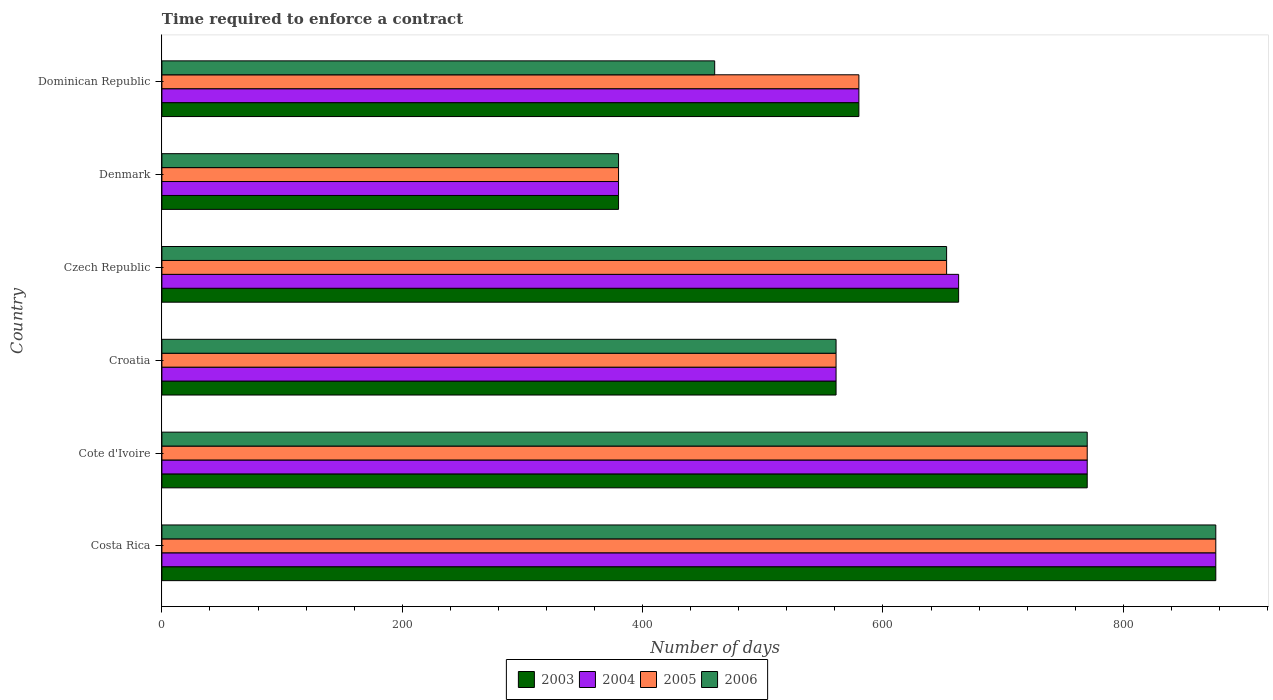How many groups of bars are there?
Give a very brief answer. 6. How many bars are there on the 4th tick from the top?
Ensure brevity in your answer.  4. What is the label of the 4th group of bars from the top?
Keep it short and to the point. Croatia. What is the number of days required to enforce a contract in 2004 in Cote d'Ivoire?
Offer a terse response. 770. Across all countries, what is the maximum number of days required to enforce a contract in 2003?
Provide a short and direct response. 877. Across all countries, what is the minimum number of days required to enforce a contract in 2006?
Provide a succinct answer. 380. In which country was the number of days required to enforce a contract in 2003 maximum?
Your answer should be compact. Costa Rica. In which country was the number of days required to enforce a contract in 2005 minimum?
Ensure brevity in your answer.  Denmark. What is the total number of days required to enforce a contract in 2005 in the graph?
Offer a very short reply. 3821. What is the difference between the number of days required to enforce a contract in 2005 in Croatia and that in Denmark?
Keep it short and to the point. 181. What is the difference between the number of days required to enforce a contract in 2005 in Croatia and the number of days required to enforce a contract in 2004 in Costa Rica?
Offer a very short reply. -316. What is the average number of days required to enforce a contract in 2006 per country?
Make the answer very short. 616.83. In how many countries, is the number of days required to enforce a contract in 2004 greater than 840 days?
Your answer should be very brief. 1. What is the ratio of the number of days required to enforce a contract in 2006 in Czech Republic to that in Denmark?
Provide a short and direct response. 1.72. Is the number of days required to enforce a contract in 2005 in Cote d'Ivoire less than that in Dominican Republic?
Your response must be concise. No. Is the difference between the number of days required to enforce a contract in 2004 in Cote d'Ivoire and Dominican Republic greater than the difference between the number of days required to enforce a contract in 2005 in Cote d'Ivoire and Dominican Republic?
Provide a short and direct response. No. What is the difference between the highest and the second highest number of days required to enforce a contract in 2005?
Make the answer very short. 107. What is the difference between the highest and the lowest number of days required to enforce a contract in 2004?
Offer a very short reply. 497. Is the sum of the number of days required to enforce a contract in 2005 in Cote d'Ivoire and Dominican Republic greater than the maximum number of days required to enforce a contract in 2004 across all countries?
Provide a short and direct response. Yes. Is it the case that in every country, the sum of the number of days required to enforce a contract in 2003 and number of days required to enforce a contract in 2006 is greater than the sum of number of days required to enforce a contract in 2004 and number of days required to enforce a contract in 2005?
Your answer should be compact. No. What does the 3rd bar from the top in Croatia represents?
Your answer should be compact. 2004. Is it the case that in every country, the sum of the number of days required to enforce a contract in 2003 and number of days required to enforce a contract in 2005 is greater than the number of days required to enforce a contract in 2006?
Give a very brief answer. Yes. How many countries are there in the graph?
Your answer should be compact. 6. What is the difference between two consecutive major ticks on the X-axis?
Make the answer very short. 200. Are the values on the major ticks of X-axis written in scientific E-notation?
Your answer should be very brief. No. Does the graph contain any zero values?
Offer a terse response. No. How are the legend labels stacked?
Provide a succinct answer. Horizontal. What is the title of the graph?
Provide a short and direct response. Time required to enforce a contract. Does "2015" appear as one of the legend labels in the graph?
Your response must be concise. No. What is the label or title of the X-axis?
Give a very brief answer. Number of days. What is the Number of days in 2003 in Costa Rica?
Make the answer very short. 877. What is the Number of days of 2004 in Costa Rica?
Your answer should be compact. 877. What is the Number of days in 2005 in Costa Rica?
Provide a succinct answer. 877. What is the Number of days in 2006 in Costa Rica?
Your response must be concise. 877. What is the Number of days in 2003 in Cote d'Ivoire?
Provide a succinct answer. 770. What is the Number of days in 2004 in Cote d'Ivoire?
Give a very brief answer. 770. What is the Number of days of 2005 in Cote d'Ivoire?
Provide a short and direct response. 770. What is the Number of days in 2006 in Cote d'Ivoire?
Your answer should be compact. 770. What is the Number of days of 2003 in Croatia?
Offer a very short reply. 561. What is the Number of days of 2004 in Croatia?
Give a very brief answer. 561. What is the Number of days in 2005 in Croatia?
Your response must be concise. 561. What is the Number of days in 2006 in Croatia?
Give a very brief answer. 561. What is the Number of days in 2003 in Czech Republic?
Your response must be concise. 663. What is the Number of days in 2004 in Czech Republic?
Give a very brief answer. 663. What is the Number of days of 2005 in Czech Republic?
Ensure brevity in your answer.  653. What is the Number of days of 2006 in Czech Republic?
Your answer should be very brief. 653. What is the Number of days of 2003 in Denmark?
Provide a short and direct response. 380. What is the Number of days in 2004 in Denmark?
Give a very brief answer. 380. What is the Number of days in 2005 in Denmark?
Ensure brevity in your answer.  380. What is the Number of days in 2006 in Denmark?
Ensure brevity in your answer.  380. What is the Number of days in 2003 in Dominican Republic?
Your response must be concise. 580. What is the Number of days in 2004 in Dominican Republic?
Offer a terse response. 580. What is the Number of days of 2005 in Dominican Republic?
Give a very brief answer. 580. What is the Number of days in 2006 in Dominican Republic?
Provide a short and direct response. 460. Across all countries, what is the maximum Number of days in 2003?
Give a very brief answer. 877. Across all countries, what is the maximum Number of days of 2004?
Offer a terse response. 877. Across all countries, what is the maximum Number of days of 2005?
Give a very brief answer. 877. Across all countries, what is the maximum Number of days of 2006?
Offer a terse response. 877. Across all countries, what is the minimum Number of days in 2003?
Your answer should be very brief. 380. Across all countries, what is the minimum Number of days in 2004?
Provide a short and direct response. 380. Across all countries, what is the minimum Number of days in 2005?
Provide a short and direct response. 380. Across all countries, what is the minimum Number of days in 2006?
Your answer should be compact. 380. What is the total Number of days in 2003 in the graph?
Offer a very short reply. 3831. What is the total Number of days of 2004 in the graph?
Keep it short and to the point. 3831. What is the total Number of days of 2005 in the graph?
Provide a short and direct response. 3821. What is the total Number of days in 2006 in the graph?
Your answer should be very brief. 3701. What is the difference between the Number of days of 2003 in Costa Rica and that in Cote d'Ivoire?
Offer a very short reply. 107. What is the difference between the Number of days of 2004 in Costa Rica and that in Cote d'Ivoire?
Offer a very short reply. 107. What is the difference between the Number of days in 2005 in Costa Rica and that in Cote d'Ivoire?
Your response must be concise. 107. What is the difference between the Number of days in 2006 in Costa Rica and that in Cote d'Ivoire?
Ensure brevity in your answer.  107. What is the difference between the Number of days in 2003 in Costa Rica and that in Croatia?
Your answer should be very brief. 316. What is the difference between the Number of days of 2004 in Costa Rica and that in Croatia?
Your answer should be very brief. 316. What is the difference between the Number of days of 2005 in Costa Rica and that in Croatia?
Make the answer very short. 316. What is the difference between the Number of days in 2006 in Costa Rica and that in Croatia?
Make the answer very short. 316. What is the difference between the Number of days in 2003 in Costa Rica and that in Czech Republic?
Give a very brief answer. 214. What is the difference between the Number of days of 2004 in Costa Rica and that in Czech Republic?
Your response must be concise. 214. What is the difference between the Number of days of 2005 in Costa Rica and that in Czech Republic?
Offer a very short reply. 224. What is the difference between the Number of days in 2006 in Costa Rica and that in Czech Republic?
Keep it short and to the point. 224. What is the difference between the Number of days of 2003 in Costa Rica and that in Denmark?
Your response must be concise. 497. What is the difference between the Number of days in 2004 in Costa Rica and that in Denmark?
Make the answer very short. 497. What is the difference between the Number of days in 2005 in Costa Rica and that in Denmark?
Offer a very short reply. 497. What is the difference between the Number of days of 2006 in Costa Rica and that in Denmark?
Your answer should be very brief. 497. What is the difference between the Number of days in 2003 in Costa Rica and that in Dominican Republic?
Keep it short and to the point. 297. What is the difference between the Number of days in 2004 in Costa Rica and that in Dominican Republic?
Provide a succinct answer. 297. What is the difference between the Number of days of 2005 in Costa Rica and that in Dominican Republic?
Your response must be concise. 297. What is the difference between the Number of days of 2006 in Costa Rica and that in Dominican Republic?
Keep it short and to the point. 417. What is the difference between the Number of days of 2003 in Cote d'Ivoire and that in Croatia?
Your response must be concise. 209. What is the difference between the Number of days of 2004 in Cote d'Ivoire and that in Croatia?
Make the answer very short. 209. What is the difference between the Number of days of 2005 in Cote d'Ivoire and that in Croatia?
Provide a short and direct response. 209. What is the difference between the Number of days of 2006 in Cote d'Ivoire and that in Croatia?
Give a very brief answer. 209. What is the difference between the Number of days of 2003 in Cote d'Ivoire and that in Czech Republic?
Your answer should be compact. 107. What is the difference between the Number of days in 2004 in Cote d'Ivoire and that in Czech Republic?
Keep it short and to the point. 107. What is the difference between the Number of days of 2005 in Cote d'Ivoire and that in Czech Republic?
Make the answer very short. 117. What is the difference between the Number of days of 2006 in Cote d'Ivoire and that in Czech Republic?
Your response must be concise. 117. What is the difference between the Number of days of 2003 in Cote d'Ivoire and that in Denmark?
Your answer should be very brief. 390. What is the difference between the Number of days in 2004 in Cote d'Ivoire and that in Denmark?
Make the answer very short. 390. What is the difference between the Number of days in 2005 in Cote d'Ivoire and that in Denmark?
Your answer should be very brief. 390. What is the difference between the Number of days in 2006 in Cote d'Ivoire and that in Denmark?
Keep it short and to the point. 390. What is the difference between the Number of days in 2003 in Cote d'Ivoire and that in Dominican Republic?
Offer a very short reply. 190. What is the difference between the Number of days in 2004 in Cote d'Ivoire and that in Dominican Republic?
Provide a short and direct response. 190. What is the difference between the Number of days in 2005 in Cote d'Ivoire and that in Dominican Republic?
Provide a succinct answer. 190. What is the difference between the Number of days in 2006 in Cote d'Ivoire and that in Dominican Republic?
Offer a very short reply. 310. What is the difference between the Number of days in 2003 in Croatia and that in Czech Republic?
Offer a very short reply. -102. What is the difference between the Number of days of 2004 in Croatia and that in Czech Republic?
Give a very brief answer. -102. What is the difference between the Number of days of 2005 in Croatia and that in Czech Republic?
Give a very brief answer. -92. What is the difference between the Number of days in 2006 in Croatia and that in Czech Republic?
Provide a short and direct response. -92. What is the difference between the Number of days in 2003 in Croatia and that in Denmark?
Ensure brevity in your answer.  181. What is the difference between the Number of days in 2004 in Croatia and that in Denmark?
Keep it short and to the point. 181. What is the difference between the Number of days in 2005 in Croatia and that in Denmark?
Offer a terse response. 181. What is the difference between the Number of days of 2006 in Croatia and that in Denmark?
Make the answer very short. 181. What is the difference between the Number of days in 2006 in Croatia and that in Dominican Republic?
Your answer should be compact. 101. What is the difference between the Number of days of 2003 in Czech Republic and that in Denmark?
Give a very brief answer. 283. What is the difference between the Number of days of 2004 in Czech Republic and that in Denmark?
Offer a very short reply. 283. What is the difference between the Number of days of 2005 in Czech Republic and that in Denmark?
Keep it short and to the point. 273. What is the difference between the Number of days of 2006 in Czech Republic and that in Denmark?
Your answer should be compact. 273. What is the difference between the Number of days of 2003 in Czech Republic and that in Dominican Republic?
Ensure brevity in your answer.  83. What is the difference between the Number of days in 2004 in Czech Republic and that in Dominican Republic?
Provide a short and direct response. 83. What is the difference between the Number of days of 2006 in Czech Republic and that in Dominican Republic?
Provide a succinct answer. 193. What is the difference between the Number of days in 2003 in Denmark and that in Dominican Republic?
Give a very brief answer. -200. What is the difference between the Number of days of 2004 in Denmark and that in Dominican Republic?
Your response must be concise. -200. What is the difference between the Number of days in 2005 in Denmark and that in Dominican Republic?
Provide a short and direct response. -200. What is the difference between the Number of days in 2006 in Denmark and that in Dominican Republic?
Make the answer very short. -80. What is the difference between the Number of days in 2003 in Costa Rica and the Number of days in 2004 in Cote d'Ivoire?
Offer a very short reply. 107. What is the difference between the Number of days in 2003 in Costa Rica and the Number of days in 2005 in Cote d'Ivoire?
Your response must be concise. 107. What is the difference between the Number of days of 2003 in Costa Rica and the Number of days of 2006 in Cote d'Ivoire?
Provide a succinct answer. 107. What is the difference between the Number of days of 2004 in Costa Rica and the Number of days of 2005 in Cote d'Ivoire?
Your answer should be very brief. 107. What is the difference between the Number of days of 2004 in Costa Rica and the Number of days of 2006 in Cote d'Ivoire?
Make the answer very short. 107. What is the difference between the Number of days in 2005 in Costa Rica and the Number of days in 2006 in Cote d'Ivoire?
Keep it short and to the point. 107. What is the difference between the Number of days of 2003 in Costa Rica and the Number of days of 2004 in Croatia?
Offer a terse response. 316. What is the difference between the Number of days of 2003 in Costa Rica and the Number of days of 2005 in Croatia?
Your answer should be very brief. 316. What is the difference between the Number of days in 2003 in Costa Rica and the Number of days in 2006 in Croatia?
Make the answer very short. 316. What is the difference between the Number of days of 2004 in Costa Rica and the Number of days of 2005 in Croatia?
Provide a succinct answer. 316. What is the difference between the Number of days in 2004 in Costa Rica and the Number of days in 2006 in Croatia?
Your answer should be very brief. 316. What is the difference between the Number of days in 2005 in Costa Rica and the Number of days in 2006 in Croatia?
Provide a short and direct response. 316. What is the difference between the Number of days in 2003 in Costa Rica and the Number of days in 2004 in Czech Republic?
Make the answer very short. 214. What is the difference between the Number of days in 2003 in Costa Rica and the Number of days in 2005 in Czech Republic?
Provide a succinct answer. 224. What is the difference between the Number of days of 2003 in Costa Rica and the Number of days of 2006 in Czech Republic?
Offer a very short reply. 224. What is the difference between the Number of days in 2004 in Costa Rica and the Number of days in 2005 in Czech Republic?
Your answer should be compact. 224. What is the difference between the Number of days in 2004 in Costa Rica and the Number of days in 2006 in Czech Republic?
Your answer should be compact. 224. What is the difference between the Number of days of 2005 in Costa Rica and the Number of days of 2006 in Czech Republic?
Provide a succinct answer. 224. What is the difference between the Number of days of 2003 in Costa Rica and the Number of days of 2004 in Denmark?
Give a very brief answer. 497. What is the difference between the Number of days of 2003 in Costa Rica and the Number of days of 2005 in Denmark?
Offer a terse response. 497. What is the difference between the Number of days in 2003 in Costa Rica and the Number of days in 2006 in Denmark?
Ensure brevity in your answer.  497. What is the difference between the Number of days of 2004 in Costa Rica and the Number of days of 2005 in Denmark?
Make the answer very short. 497. What is the difference between the Number of days of 2004 in Costa Rica and the Number of days of 2006 in Denmark?
Your answer should be very brief. 497. What is the difference between the Number of days in 2005 in Costa Rica and the Number of days in 2006 in Denmark?
Your answer should be very brief. 497. What is the difference between the Number of days in 2003 in Costa Rica and the Number of days in 2004 in Dominican Republic?
Provide a succinct answer. 297. What is the difference between the Number of days in 2003 in Costa Rica and the Number of days in 2005 in Dominican Republic?
Give a very brief answer. 297. What is the difference between the Number of days of 2003 in Costa Rica and the Number of days of 2006 in Dominican Republic?
Ensure brevity in your answer.  417. What is the difference between the Number of days in 2004 in Costa Rica and the Number of days in 2005 in Dominican Republic?
Give a very brief answer. 297. What is the difference between the Number of days in 2004 in Costa Rica and the Number of days in 2006 in Dominican Republic?
Give a very brief answer. 417. What is the difference between the Number of days of 2005 in Costa Rica and the Number of days of 2006 in Dominican Republic?
Provide a short and direct response. 417. What is the difference between the Number of days in 2003 in Cote d'Ivoire and the Number of days in 2004 in Croatia?
Give a very brief answer. 209. What is the difference between the Number of days in 2003 in Cote d'Ivoire and the Number of days in 2005 in Croatia?
Your answer should be compact. 209. What is the difference between the Number of days in 2003 in Cote d'Ivoire and the Number of days in 2006 in Croatia?
Your answer should be compact. 209. What is the difference between the Number of days of 2004 in Cote d'Ivoire and the Number of days of 2005 in Croatia?
Keep it short and to the point. 209. What is the difference between the Number of days in 2004 in Cote d'Ivoire and the Number of days in 2006 in Croatia?
Give a very brief answer. 209. What is the difference between the Number of days in 2005 in Cote d'Ivoire and the Number of days in 2006 in Croatia?
Keep it short and to the point. 209. What is the difference between the Number of days of 2003 in Cote d'Ivoire and the Number of days of 2004 in Czech Republic?
Ensure brevity in your answer.  107. What is the difference between the Number of days of 2003 in Cote d'Ivoire and the Number of days of 2005 in Czech Republic?
Give a very brief answer. 117. What is the difference between the Number of days in 2003 in Cote d'Ivoire and the Number of days in 2006 in Czech Republic?
Your answer should be compact. 117. What is the difference between the Number of days of 2004 in Cote d'Ivoire and the Number of days of 2005 in Czech Republic?
Provide a short and direct response. 117. What is the difference between the Number of days of 2004 in Cote d'Ivoire and the Number of days of 2006 in Czech Republic?
Your answer should be very brief. 117. What is the difference between the Number of days of 2005 in Cote d'Ivoire and the Number of days of 2006 in Czech Republic?
Your response must be concise. 117. What is the difference between the Number of days in 2003 in Cote d'Ivoire and the Number of days in 2004 in Denmark?
Make the answer very short. 390. What is the difference between the Number of days of 2003 in Cote d'Ivoire and the Number of days of 2005 in Denmark?
Provide a succinct answer. 390. What is the difference between the Number of days of 2003 in Cote d'Ivoire and the Number of days of 2006 in Denmark?
Ensure brevity in your answer.  390. What is the difference between the Number of days of 2004 in Cote d'Ivoire and the Number of days of 2005 in Denmark?
Make the answer very short. 390. What is the difference between the Number of days in 2004 in Cote d'Ivoire and the Number of days in 2006 in Denmark?
Provide a succinct answer. 390. What is the difference between the Number of days of 2005 in Cote d'Ivoire and the Number of days of 2006 in Denmark?
Provide a succinct answer. 390. What is the difference between the Number of days in 2003 in Cote d'Ivoire and the Number of days in 2004 in Dominican Republic?
Your answer should be very brief. 190. What is the difference between the Number of days in 2003 in Cote d'Ivoire and the Number of days in 2005 in Dominican Republic?
Offer a terse response. 190. What is the difference between the Number of days in 2003 in Cote d'Ivoire and the Number of days in 2006 in Dominican Republic?
Make the answer very short. 310. What is the difference between the Number of days in 2004 in Cote d'Ivoire and the Number of days in 2005 in Dominican Republic?
Your answer should be compact. 190. What is the difference between the Number of days of 2004 in Cote d'Ivoire and the Number of days of 2006 in Dominican Republic?
Give a very brief answer. 310. What is the difference between the Number of days of 2005 in Cote d'Ivoire and the Number of days of 2006 in Dominican Republic?
Offer a terse response. 310. What is the difference between the Number of days of 2003 in Croatia and the Number of days of 2004 in Czech Republic?
Ensure brevity in your answer.  -102. What is the difference between the Number of days in 2003 in Croatia and the Number of days in 2005 in Czech Republic?
Offer a very short reply. -92. What is the difference between the Number of days of 2003 in Croatia and the Number of days of 2006 in Czech Republic?
Give a very brief answer. -92. What is the difference between the Number of days in 2004 in Croatia and the Number of days in 2005 in Czech Republic?
Your answer should be compact. -92. What is the difference between the Number of days of 2004 in Croatia and the Number of days of 2006 in Czech Republic?
Keep it short and to the point. -92. What is the difference between the Number of days in 2005 in Croatia and the Number of days in 2006 in Czech Republic?
Provide a succinct answer. -92. What is the difference between the Number of days of 2003 in Croatia and the Number of days of 2004 in Denmark?
Ensure brevity in your answer.  181. What is the difference between the Number of days of 2003 in Croatia and the Number of days of 2005 in Denmark?
Provide a succinct answer. 181. What is the difference between the Number of days in 2003 in Croatia and the Number of days in 2006 in Denmark?
Ensure brevity in your answer.  181. What is the difference between the Number of days in 2004 in Croatia and the Number of days in 2005 in Denmark?
Keep it short and to the point. 181. What is the difference between the Number of days of 2004 in Croatia and the Number of days of 2006 in Denmark?
Give a very brief answer. 181. What is the difference between the Number of days in 2005 in Croatia and the Number of days in 2006 in Denmark?
Offer a terse response. 181. What is the difference between the Number of days of 2003 in Croatia and the Number of days of 2004 in Dominican Republic?
Make the answer very short. -19. What is the difference between the Number of days of 2003 in Croatia and the Number of days of 2006 in Dominican Republic?
Your answer should be compact. 101. What is the difference between the Number of days of 2004 in Croatia and the Number of days of 2005 in Dominican Republic?
Offer a very short reply. -19. What is the difference between the Number of days in 2004 in Croatia and the Number of days in 2006 in Dominican Republic?
Provide a short and direct response. 101. What is the difference between the Number of days of 2005 in Croatia and the Number of days of 2006 in Dominican Republic?
Your answer should be very brief. 101. What is the difference between the Number of days of 2003 in Czech Republic and the Number of days of 2004 in Denmark?
Offer a terse response. 283. What is the difference between the Number of days of 2003 in Czech Republic and the Number of days of 2005 in Denmark?
Your answer should be compact. 283. What is the difference between the Number of days of 2003 in Czech Republic and the Number of days of 2006 in Denmark?
Keep it short and to the point. 283. What is the difference between the Number of days of 2004 in Czech Republic and the Number of days of 2005 in Denmark?
Your answer should be very brief. 283. What is the difference between the Number of days in 2004 in Czech Republic and the Number of days in 2006 in Denmark?
Your answer should be compact. 283. What is the difference between the Number of days of 2005 in Czech Republic and the Number of days of 2006 in Denmark?
Offer a terse response. 273. What is the difference between the Number of days of 2003 in Czech Republic and the Number of days of 2005 in Dominican Republic?
Your response must be concise. 83. What is the difference between the Number of days of 2003 in Czech Republic and the Number of days of 2006 in Dominican Republic?
Ensure brevity in your answer.  203. What is the difference between the Number of days of 2004 in Czech Republic and the Number of days of 2005 in Dominican Republic?
Your response must be concise. 83. What is the difference between the Number of days in 2004 in Czech Republic and the Number of days in 2006 in Dominican Republic?
Your answer should be very brief. 203. What is the difference between the Number of days in 2005 in Czech Republic and the Number of days in 2006 in Dominican Republic?
Make the answer very short. 193. What is the difference between the Number of days of 2003 in Denmark and the Number of days of 2004 in Dominican Republic?
Ensure brevity in your answer.  -200. What is the difference between the Number of days of 2003 in Denmark and the Number of days of 2005 in Dominican Republic?
Your answer should be very brief. -200. What is the difference between the Number of days of 2003 in Denmark and the Number of days of 2006 in Dominican Republic?
Your answer should be very brief. -80. What is the difference between the Number of days in 2004 in Denmark and the Number of days in 2005 in Dominican Republic?
Provide a short and direct response. -200. What is the difference between the Number of days of 2004 in Denmark and the Number of days of 2006 in Dominican Republic?
Provide a succinct answer. -80. What is the difference between the Number of days of 2005 in Denmark and the Number of days of 2006 in Dominican Republic?
Give a very brief answer. -80. What is the average Number of days in 2003 per country?
Your answer should be compact. 638.5. What is the average Number of days of 2004 per country?
Offer a very short reply. 638.5. What is the average Number of days of 2005 per country?
Your answer should be compact. 636.83. What is the average Number of days of 2006 per country?
Keep it short and to the point. 616.83. What is the difference between the Number of days of 2003 and Number of days of 2004 in Costa Rica?
Your answer should be very brief. 0. What is the difference between the Number of days in 2003 and Number of days in 2005 in Costa Rica?
Give a very brief answer. 0. What is the difference between the Number of days of 2003 and Number of days of 2006 in Costa Rica?
Your response must be concise. 0. What is the difference between the Number of days in 2004 and Number of days in 2005 in Costa Rica?
Your answer should be compact. 0. What is the difference between the Number of days of 2004 and Number of days of 2006 in Costa Rica?
Keep it short and to the point. 0. What is the difference between the Number of days in 2003 and Number of days in 2006 in Cote d'Ivoire?
Ensure brevity in your answer.  0. What is the difference between the Number of days of 2004 and Number of days of 2005 in Cote d'Ivoire?
Your response must be concise. 0. What is the difference between the Number of days of 2004 and Number of days of 2006 in Cote d'Ivoire?
Your answer should be compact. 0. What is the difference between the Number of days of 2005 and Number of days of 2006 in Cote d'Ivoire?
Give a very brief answer. 0. What is the difference between the Number of days of 2003 and Number of days of 2004 in Czech Republic?
Provide a succinct answer. 0. What is the difference between the Number of days of 2003 and Number of days of 2006 in Czech Republic?
Offer a terse response. 10. What is the difference between the Number of days in 2004 and Number of days in 2005 in Czech Republic?
Offer a terse response. 10. What is the difference between the Number of days in 2005 and Number of days in 2006 in Czech Republic?
Your answer should be very brief. 0. What is the difference between the Number of days in 2004 and Number of days in 2005 in Denmark?
Offer a terse response. 0. What is the difference between the Number of days of 2005 and Number of days of 2006 in Denmark?
Offer a terse response. 0. What is the difference between the Number of days in 2003 and Number of days in 2004 in Dominican Republic?
Your answer should be very brief. 0. What is the difference between the Number of days of 2003 and Number of days of 2006 in Dominican Republic?
Provide a short and direct response. 120. What is the difference between the Number of days of 2004 and Number of days of 2005 in Dominican Republic?
Your answer should be very brief. 0. What is the difference between the Number of days in 2004 and Number of days in 2006 in Dominican Republic?
Ensure brevity in your answer.  120. What is the difference between the Number of days in 2005 and Number of days in 2006 in Dominican Republic?
Your answer should be very brief. 120. What is the ratio of the Number of days of 2003 in Costa Rica to that in Cote d'Ivoire?
Provide a short and direct response. 1.14. What is the ratio of the Number of days in 2004 in Costa Rica to that in Cote d'Ivoire?
Your answer should be very brief. 1.14. What is the ratio of the Number of days of 2005 in Costa Rica to that in Cote d'Ivoire?
Your answer should be very brief. 1.14. What is the ratio of the Number of days in 2006 in Costa Rica to that in Cote d'Ivoire?
Your answer should be compact. 1.14. What is the ratio of the Number of days in 2003 in Costa Rica to that in Croatia?
Keep it short and to the point. 1.56. What is the ratio of the Number of days in 2004 in Costa Rica to that in Croatia?
Your answer should be very brief. 1.56. What is the ratio of the Number of days in 2005 in Costa Rica to that in Croatia?
Keep it short and to the point. 1.56. What is the ratio of the Number of days of 2006 in Costa Rica to that in Croatia?
Provide a succinct answer. 1.56. What is the ratio of the Number of days of 2003 in Costa Rica to that in Czech Republic?
Your response must be concise. 1.32. What is the ratio of the Number of days in 2004 in Costa Rica to that in Czech Republic?
Offer a very short reply. 1.32. What is the ratio of the Number of days in 2005 in Costa Rica to that in Czech Republic?
Your answer should be very brief. 1.34. What is the ratio of the Number of days in 2006 in Costa Rica to that in Czech Republic?
Offer a terse response. 1.34. What is the ratio of the Number of days in 2003 in Costa Rica to that in Denmark?
Make the answer very short. 2.31. What is the ratio of the Number of days in 2004 in Costa Rica to that in Denmark?
Your response must be concise. 2.31. What is the ratio of the Number of days of 2005 in Costa Rica to that in Denmark?
Ensure brevity in your answer.  2.31. What is the ratio of the Number of days in 2006 in Costa Rica to that in Denmark?
Make the answer very short. 2.31. What is the ratio of the Number of days in 2003 in Costa Rica to that in Dominican Republic?
Your response must be concise. 1.51. What is the ratio of the Number of days of 2004 in Costa Rica to that in Dominican Republic?
Make the answer very short. 1.51. What is the ratio of the Number of days of 2005 in Costa Rica to that in Dominican Republic?
Provide a short and direct response. 1.51. What is the ratio of the Number of days in 2006 in Costa Rica to that in Dominican Republic?
Provide a succinct answer. 1.91. What is the ratio of the Number of days in 2003 in Cote d'Ivoire to that in Croatia?
Your response must be concise. 1.37. What is the ratio of the Number of days of 2004 in Cote d'Ivoire to that in Croatia?
Your answer should be very brief. 1.37. What is the ratio of the Number of days of 2005 in Cote d'Ivoire to that in Croatia?
Provide a short and direct response. 1.37. What is the ratio of the Number of days in 2006 in Cote d'Ivoire to that in Croatia?
Your answer should be very brief. 1.37. What is the ratio of the Number of days of 2003 in Cote d'Ivoire to that in Czech Republic?
Keep it short and to the point. 1.16. What is the ratio of the Number of days of 2004 in Cote d'Ivoire to that in Czech Republic?
Your response must be concise. 1.16. What is the ratio of the Number of days of 2005 in Cote d'Ivoire to that in Czech Republic?
Provide a succinct answer. 1.18. What is the ratio of the Number of days in 2006 in Cote d'Ivoire to that in Czech Republic?
Offer a very short reply. 1.18. What is the ratio of the Number of days in 2003 in Cote d'Ivoire to that in Denmark?
Your answer should be very brief. 2.03. What is the ratio of the Number of days of 2004 in Cote d'Ivoire to that in Denmark?
Keep it short and to the point. 2.03. What is the ratio of the Number of days of 2005 in Cote d'Ivoire to that in Denmark?
Your answer should be very brief. 2.03. What is the ratio of the Number of days of 2006 in Cote d'Ivoire to that in Denmark?
Ensure brevity in your answer.  2.03. What is the ratio of the Number of days of 2003 in Cote d'Ivoire to that in Dominican Republic?
Your answer should be very brief. 1.33. What is the ratio of the Number of days in 2004 in Cote d'Ivoire to that in Dominican Republic?
Offer a very short reply. 1.33. What is the ratio of the Number of days in 2005 in Cote d'Ivoire to that in Dominican Republic?
Give a very brief answer. 1.33. What is the ratio of the Number of days in 2006 in Cote d'Ivoire to that in Dominican Republic?
Give a very brief answer. 1.67. What is the ratio of the Number of days in 2003 in Croatia to that in Czech Republic?
Your answer should be very brief. 0.85. What is the ratio of the Number of days of 2004 in Croatia to that in Czech Republic?
Provide a succinct answer. 0.85. What is the ratio of the Number of days in 2005 in Croatia to that in Czech Republic?
Your response must be concise. 0.86. What is the ratio of the Number of days in 2006 in Croatia to that in Czech Republic?
Provide a short and direct response. 0.86. What is the ratio of the Number of days of 2003 in Croatia to that in Denmark?
Make the answer very short. 1.48. What is the ratio of the Number of days in 2004 in Croatia to that in Denmark?
Your response must be concise. 1.48. What is the ratio of the Number of days in 2005 in Croatia to that in Denmark?
Ensure brevity in your answer.  1.48. What is the ratio of the Number of days of 2006 in Croatia to that in Denmark?
Your response must be concise. 1.48. What is the ratio of the Number of days of 2003 in Croatia to that in Dominican Republic?
Give a very brief answer. 0.97. What is the ratio of the Number of days in 2004 in Croatia to that in Dominican Republic?
Offer a very short reply. 0.97. What is the ratio of the Number of days of 2005 in Croatia to that in Dominican Republic?
Make the answer very short. 0.97. What is the ratio of the Number of days of 2006 in Croatia to that in Dominican Republic?
Offer a very short reply. 1.22. What is the ratio of the Number of days in 2003 in Czech Republic to that in Denmark?
Provide a short and direct response. 1.74. What is the ratio of the Number of days in 2004 in Czech Republic to that in Denmark?
Your answer should be compact. 1.74. What is the ratio of the Number of days of 2005 in Czech Republic to that in Denmark?
Provide a succinct answer. 1.72. What is the ratio of the Number of days in 2006 in Czech Republic to that in Denmark?
Your answer should be very brief. 1.72. What is the ratio of the Number of days in 2003 in Czech Republic to that in Dominican Republic?
Offer a terse response. 1.14. What is the ratio of the Number of days of 2004 in Czech Republic to that in Dominican Republic?
Your answer should be very brief. 1.14. What is the ratio of the Number of days in 2005 in Czech Republic to that in Dominican Republic?
Offer a terse response. 1.13. What is the ratio of the Number of days in 2006 in Czech Republic to that in Dominican Republic?
Provide a succinct answer. 1.42. What is the ratio of the Number of days in 2003 in Denmark to that in Dominican Republic?
Provide a succinct answer. 0.66. What is the ratio of the Number of days of 2004 in Denmark to that in Dominican Republic?
Keep it short and to the point. 0.66. What is the ratio of the Number of days of 2005 in Denmark to that in Dominican Republic?
Offer a terse response. 0.66. What is the ratio of the Number of days in 2006 in Denmark to that in Dominican Republic?
Provide a short and direct response. 0.83. What is the difference between the highest and the second highest Number of days of 2003?
Your answer should be very brief. 107. What is the difference between the highest and the second highest Number of days of 2004?
Offer a very short reply. 107. What is the difference between the highest and the second highest Number of days of 2005?
Make the answer very short. 107. What is the difference between the highest and the second highest Number of days in 2006?
Provide a short and direct response. 107. What is the difference between the highest and the lowest Number of days in 2003?
Ensure brevity in your answer.  497. What is the difference between the highest and the lowest Number of days of 2004?
Make the answer very short. 497. What is the difference between the highest and the lowest Number of days in 2005?
Provide a succinct answer. 497. What is the difference between the highest and the lowest Number of days in 2006?
Provide a succinct answer. 497. 